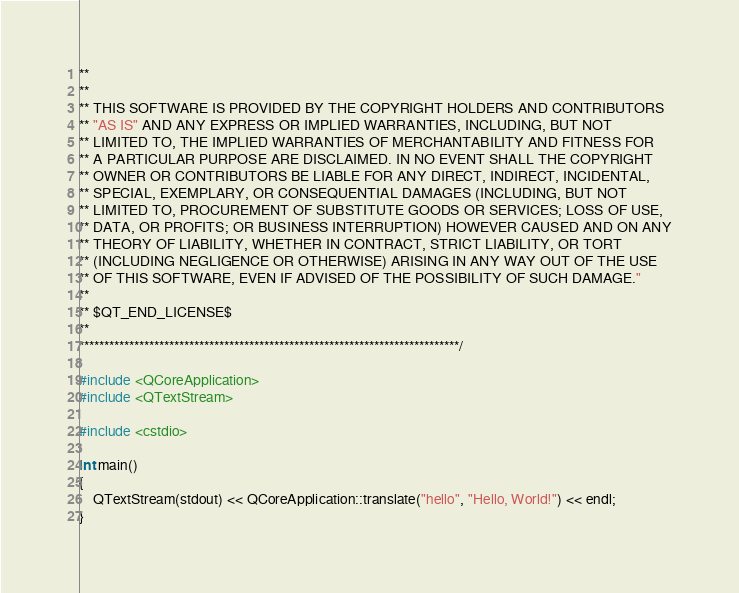<code> <loc_0><loc_0><loc_500><loc_500><_C++_>**
**
** THIS SOFTWARE IS PROVIDED BY THE COPYRIGHT HOLDERS AND CONTRIBUTORS
** "AS IS" AND ANY EXPRESS OR IMPLIED WARRANTIES, INCLUDING, BUT NOT
** LIMITED TO, THE IMPLIED WARRANTIES OF MERCHANTABILITY AND FITNESS FOR
** A PARTICULAR PURPOSE ARE DISCLAIMED. IN NO EVENT SHALL THE COPYRIGHT
** OWNER OR CONTRIBUTORS BE LIABLE FOR ANY DIRECT, INDIRECT, INCIDENTAL,
** SPECIAL, EXEMPLARY, OR CONSEQUENTIAL DAMAGES (INCLUDING, BUT NOT
** LIMITED TO, PROCUREMENT OF SUBSTITUTE GOODS OR SERVICES; LOSS OF USE,
** DATA, OR PROFITS; OR BUSINESS INTERRUPTION) HOWEVER CAUSED AND ON ANY
** THEORY OF LIABILITY, WHETHER IN CONTRACT, STRICT LIABILITY, OR TORT
** (INCLUDING NEGLIGENCE OR OTHERWISE) ARISING IN ANY WAY OUT OF THE USE
** OF THIS SOFTWARE, EVEN IF ADVISED OF THE POSSIBILITY OF SUCH DAMAGE."
**
** $QT_END_LICENSE$
**
****************************************************************************/

#include <QCoreApplication>
#include <QTextStream>

#include <cstdio>

int main()
{
    QTextStream(stdout) << QCoreApplication::translate("hello", "Hello, World!") << endl;
}
</code> 